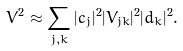Convert formula to latex. <formula><loc_0><loc_0><loc_500><loc_500>\bar { V } ^ { 2 } \approx \sum _ { j , k } | c _ { j } | ^ { 2 } | V _ { j k } | ^ { 2 } | d _ { k } | ^ { 2 } .</formula> 